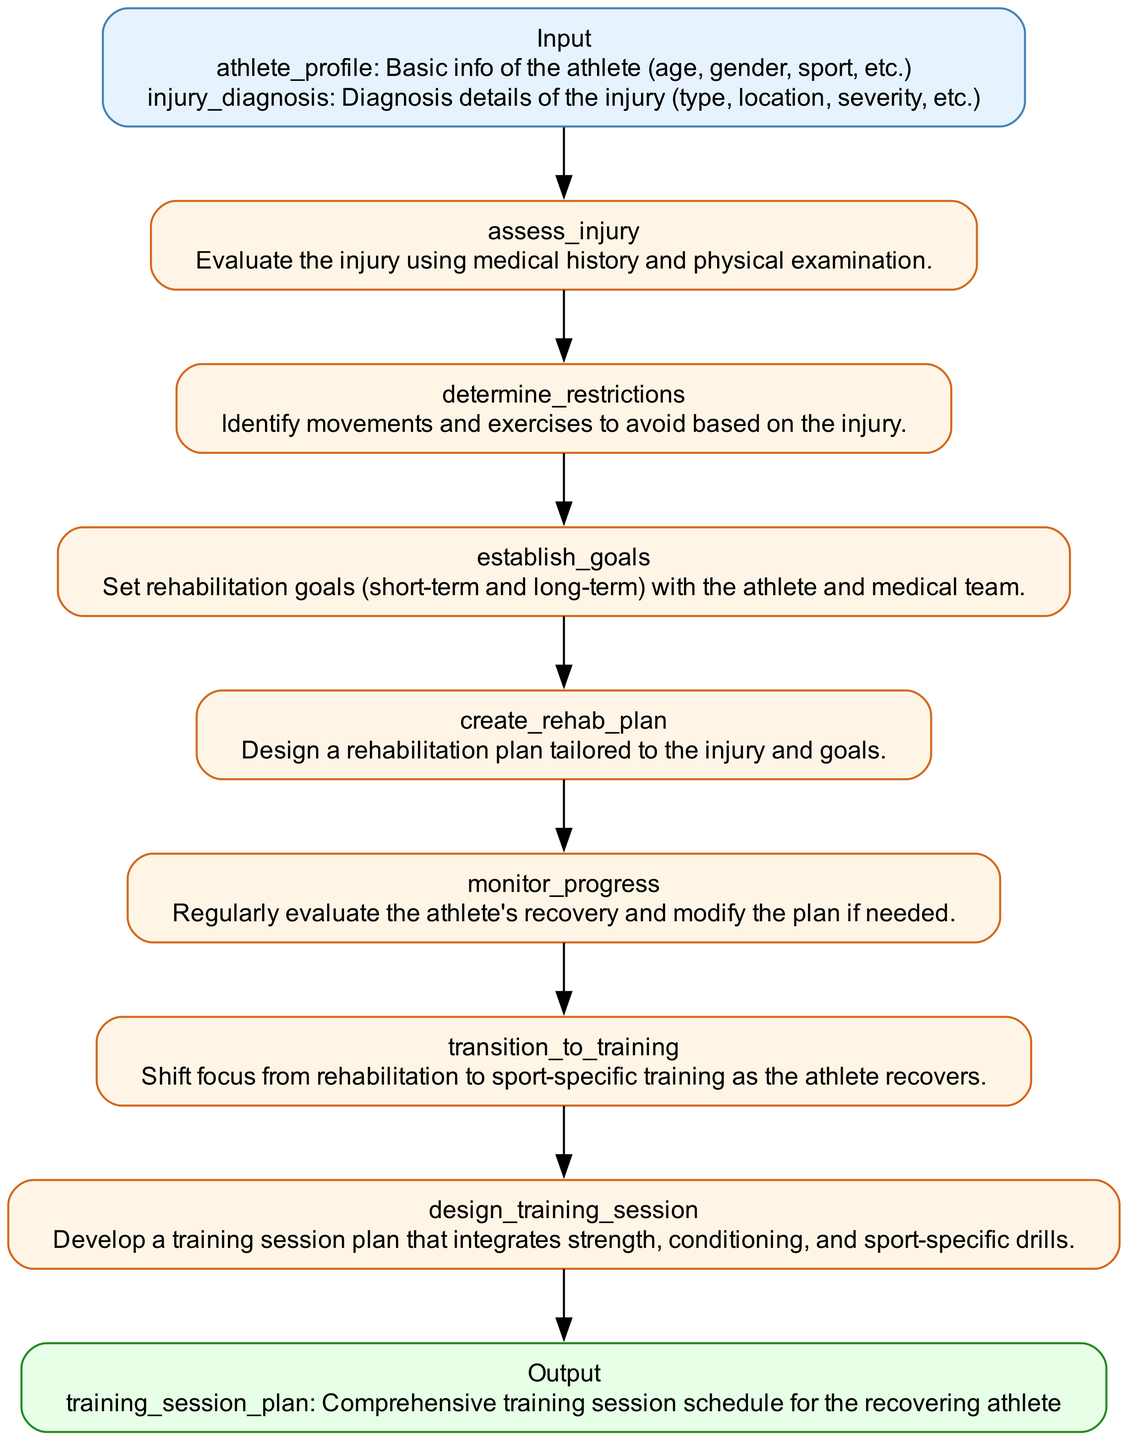What are the two input parameters in the diagram? The diagram lists "athlete_profile" and "injury_diagnosis" as the input parameters. Both parameters provide essential information for the injury assessment process.
Answer: athlete profile, injury diagnosis What is the first step in the process? According to the diagram, the first step listed is "assess_injury," which involves evaluating the injury using medical history and physical examination. This step is crucial for determining the athlete's condition.
Answer: assess injury How many steps are there in total? The diagram outlines six distinct steps to transition from injury assessment to training session design. This includes assessing injury, determining restrictions, establishing goals, creating a rehab plan, monitoring progress, and transitioning to training.
Answer: six What is the output of the process? The output, as specified in the diagram, is "training_session_plan," which represents a comprehensive training session schedule tailored for the recovering athlete. This plan is a critical result of the process.
Answer: training session plan Which step comes immediately after establishing goals? Following "establish_goals," the next step in the flowchart is "create_rehab_plan." This logical progression emphasizes the design of a rehabilitation strategy based on the set objectives.
Answer: create rehab plan What color represents the input node? The input node in the diagram is filled with a light blue color (#E6F3FF) and has a border color of dark blue (#4682B4). This color scheme visually distinguishes the input from other nodes.
Answer: light blue During which step do the medical team and athlete set rehabilitation goals? The step where rehabilitation goals are set is specifically identified in the diagram as "establish_goals." This collaborative process is essential for guiding the recovery plan.
Answer: establish goals What is identified in the "determine_restrictions" step? The "determine_restrictions" step involves identifying movements and exercises that should be avoided due to the athlete's injury. This precaution is vital for ensuring safety during recovery.
Answer: movements and exercises to avoid In which part of the diagram does transition to training begin? The transition to training begins at the step labeled "transition_to_training." This step signifies a shift in focus from rehabilitation towards more sport-specific training regimens as the athlete’s condition improves.
Answer: transition to training 